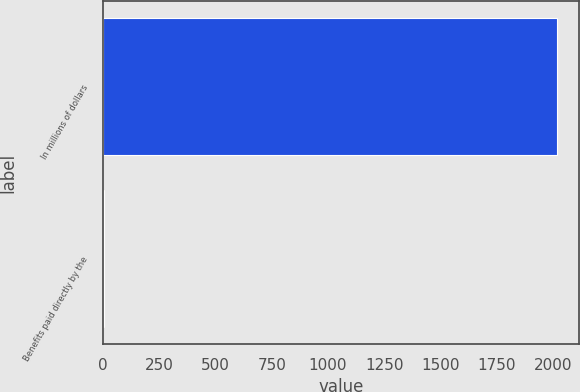Convert chart. <chart><loc_0><loc_0><loc_500><loc_500><bar_chart><fcel>In millions of dollars<fcel>Benefits paid directly by the<nl><fcel>2017<fcel>5<nl></chart> 